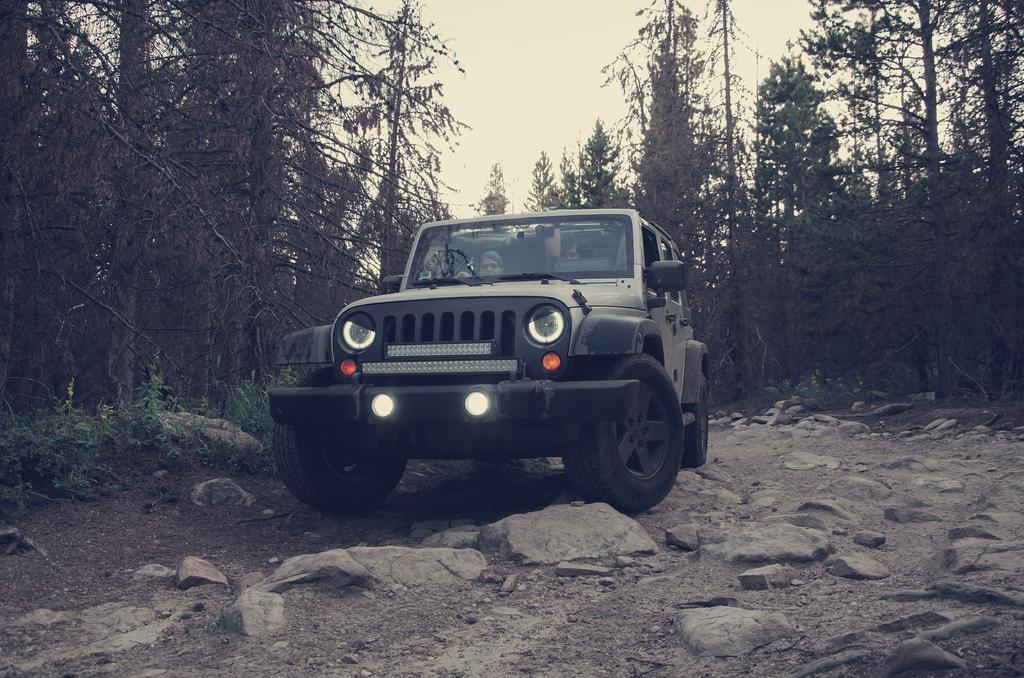How would you summarize this image in a sentence or two? In this image there is a person sitting in a vehicle which is moving on the path, on the path there are rocks and on the either side of the path there are trees. In the background there is the sky. 